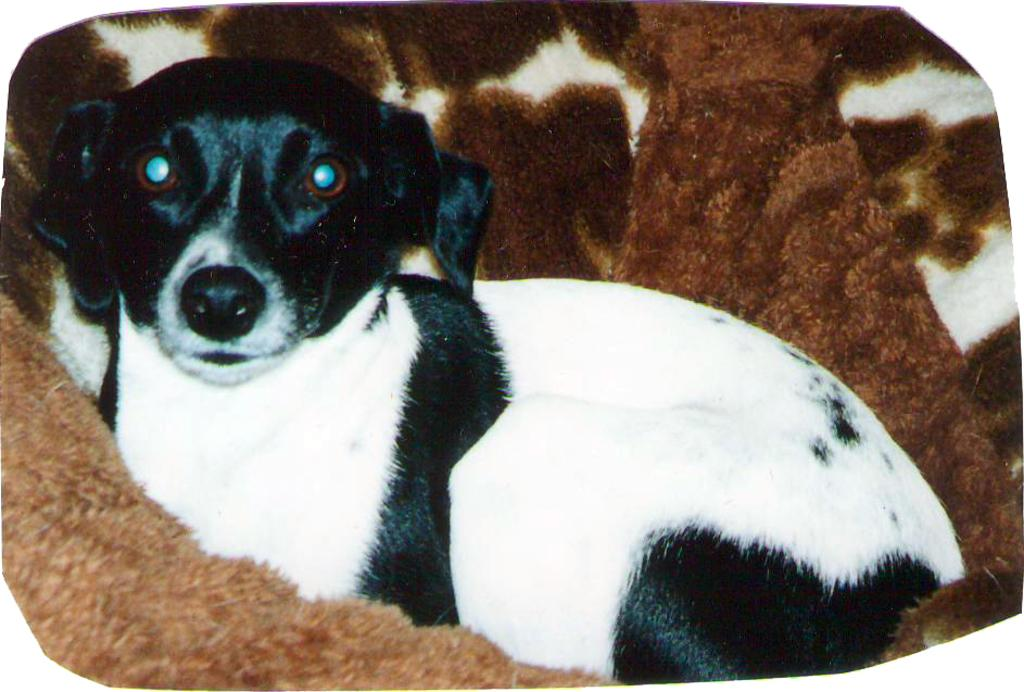What animal can be seen in the image? There is a dog in the image. Where is the dog located in the image? The dog is sitting on a couch. Can you describe the position of the dog in the image? The dog is in the center of the image. What type of soup is being served at the playground in the image? There is no soup or playground present in the image; it features a dog sitting on a couch. 